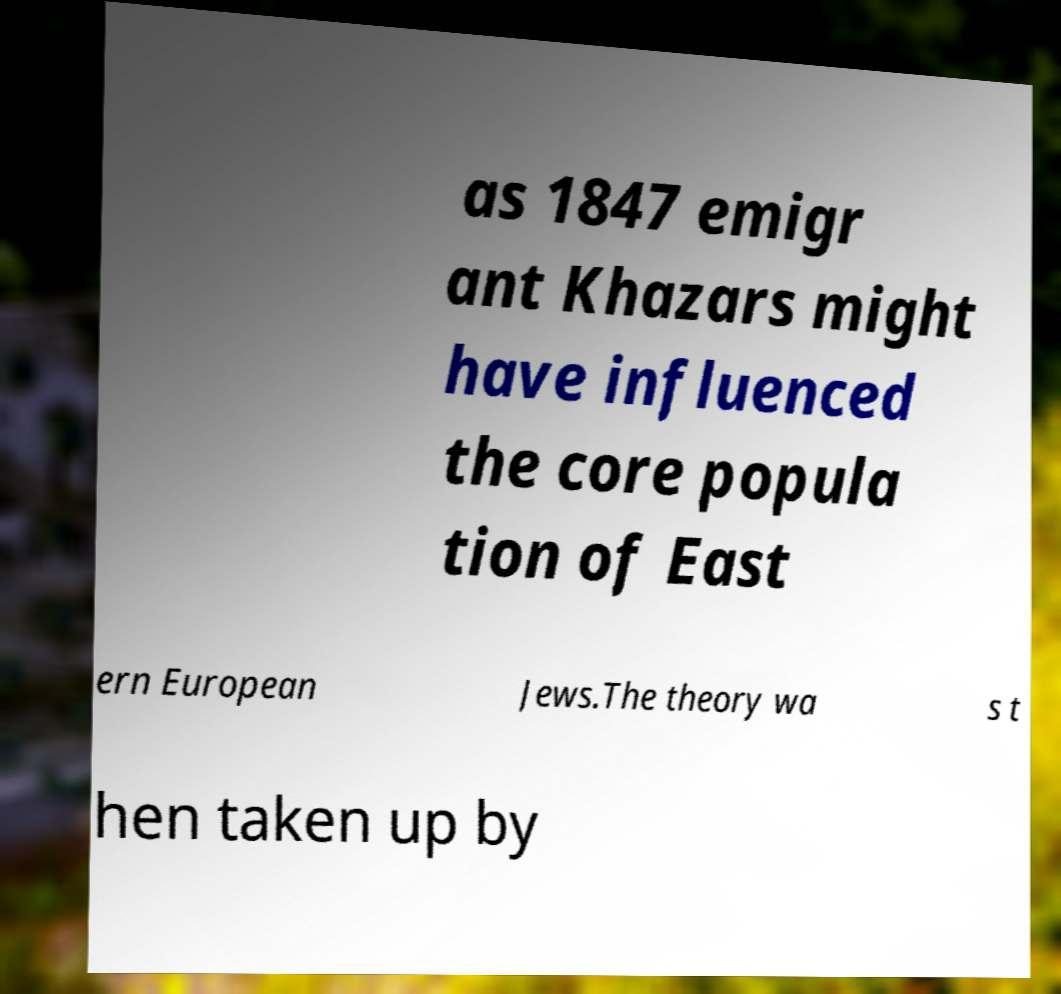What messages or text are displayed in this image? I need them in a readable, typed format. as 1847 emigr ant Khazars might have influenced the core popula tion of East ern European Jews.The theory wa s t hen taken up by 